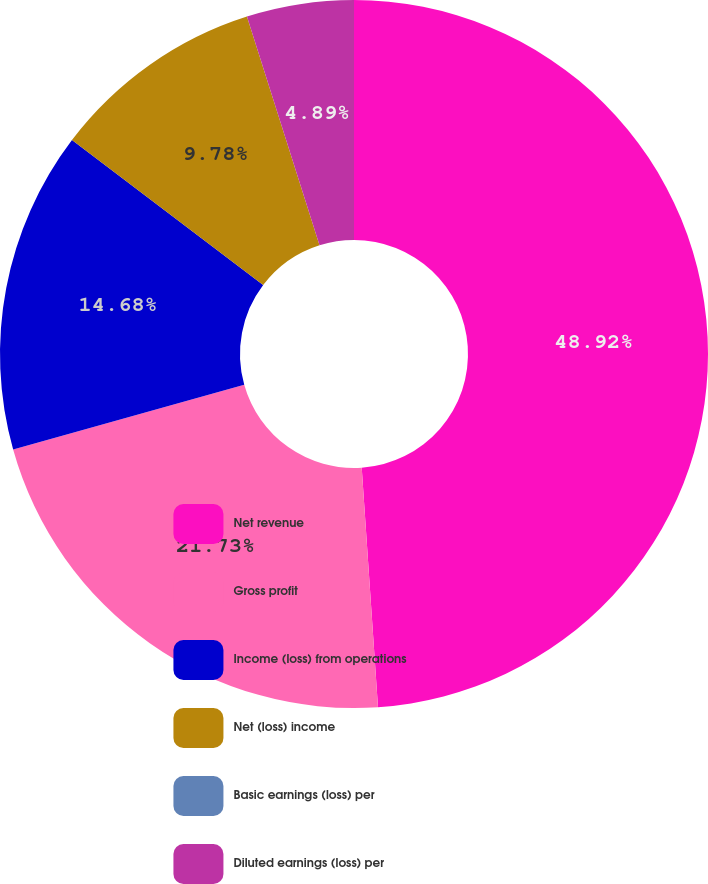<chart> <loc_0><loc_0><loc_500><loc_500><pie_chart><fcel>Net revenue<fcel>Gross profit<fcel>Income (loss) from operations<fcel>Net (loss) income<fcel>Basic earnings (loss) per<fcel>Diluted earnings (loss) per<nl><fcel>48.92%<fcel>21.73%<fcel>14.68%<fcel>9.78%<fcel>0.0%<fcel>4.89%<nl></chart> 